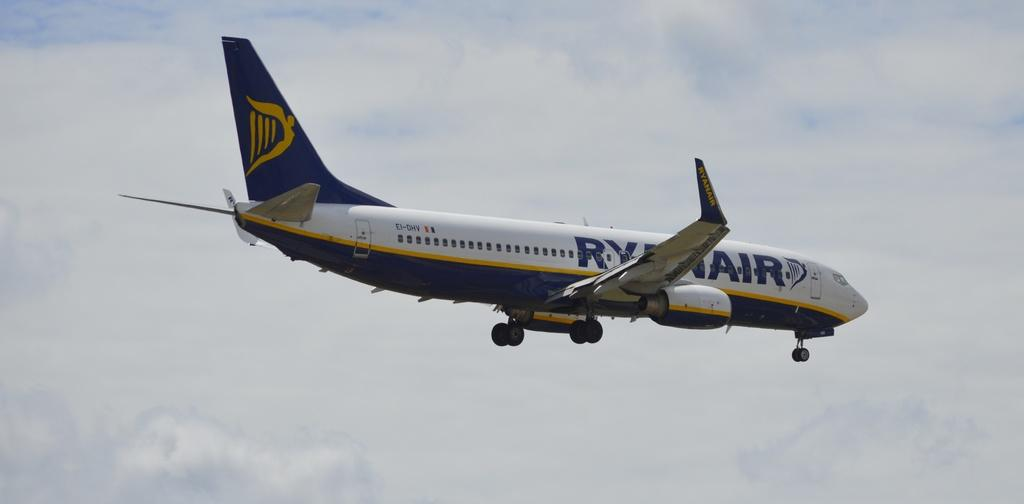What is the main subject of the image? The main subject of the image is an airplane. Where is the airplane located in the image? The airplane is in the sky. What type of skirt is the carpenter wearing in the image? There is no carpenter or skirt present in the image; it features an airplane in the sky. What role does the actor play in the image? There is no actor present in the image; it features an airplane in the sky. 